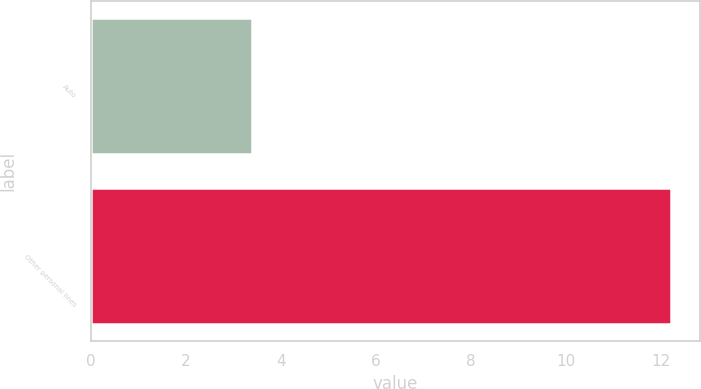Convert chart. <chart><loc_0><loc_0><loc_500><loc_500><bar_chart><fcel>Auto<fcel>Other personal lines<nl><fcel>3.4<fcel>12.2<nl></chart> 